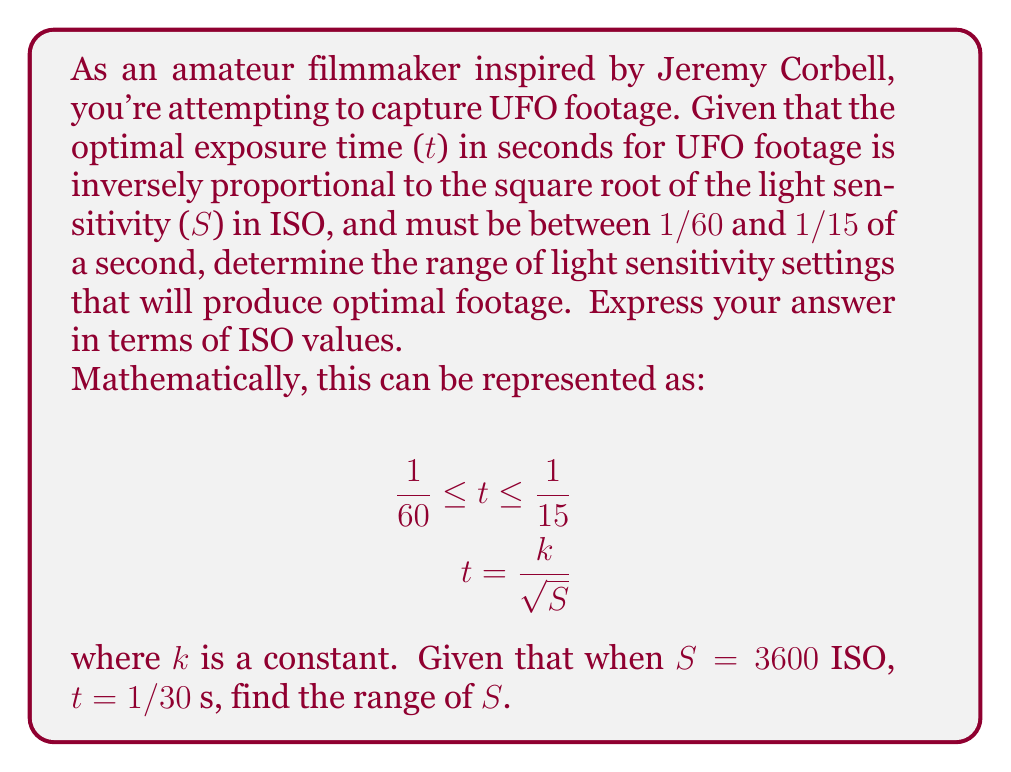Teach me how to tackle this problem. Let's approach this step-by-step:

1) First, we need to find the value of k. We know that when S = 3600 ISO, t = 1/30 s. Let's substitute these values into the equation:

   $$\frac{1}{30} = \frac{k}{\sqrt{3600}}$$

2) Simplify:
   $$\frac{1}{30} = \frac{k}{60}$$

3) Solve for k:
   $$k = \frac{60}{30} = 2$$

4) Now that we know k = 2, we can rewrite our original inequality:

   $$\frac{1}{60} \leq \frac{2}{\sqrt{S}} \leq \frac{1}{15}$$

5) Let's solve the left inequality first:
   $$\frac{1}{60} \leq \frac{2}{\sqrt{S}}$$
   $$\sqrt{S} \leq 120$$
   $$S \leq 14400$$

6) Now the right inequality:
   $$\frac{2}{\sqrt{S}} \leq \frac{1}{15}$$
   $$\sqrt{S} \geq 30$$
   $$S \geq 900$$

7) Combining these results, we get:

   $$900 \leq S \leq 14400$$

Therefore, the optimal range for light sensitivity is between 900 ISO and 14400 ISO.
Answer: 900 ISO $\leq S \leq$ 14400 ISO 